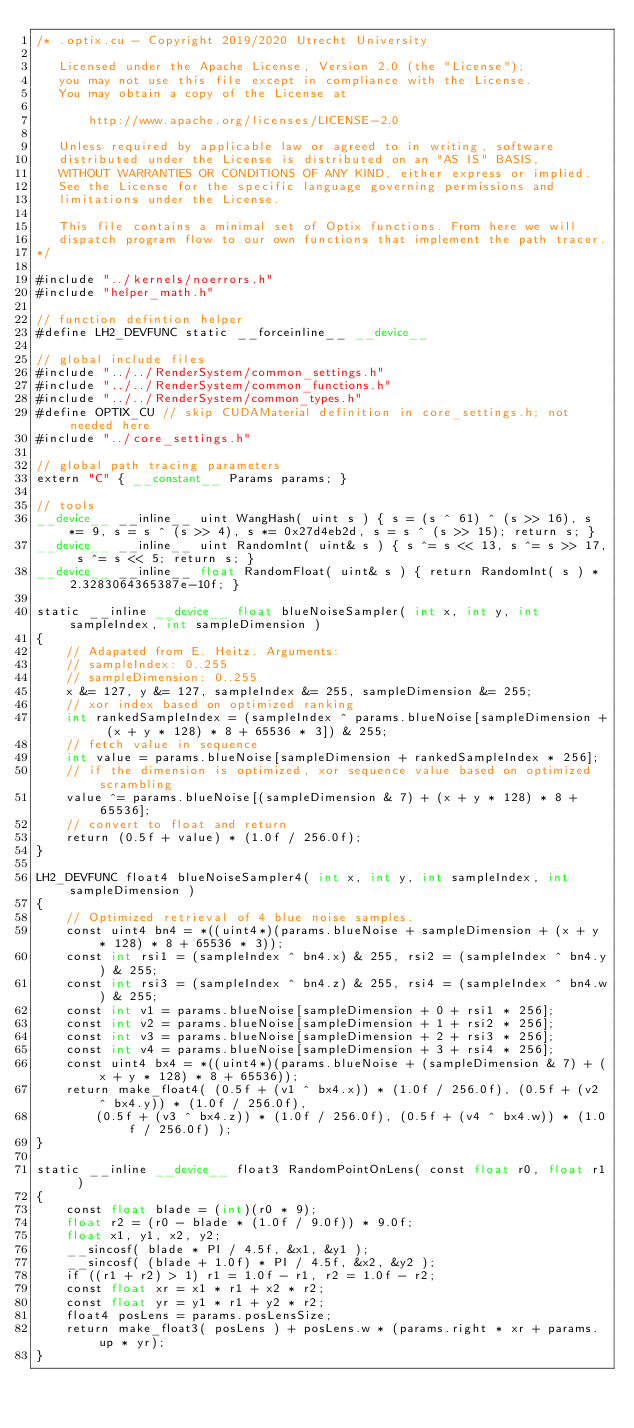Convert code to text. <code><loc_0><loc_0><loc_500><loc_500><_Cuda_>/* .optix.cu - Copyright 2019/2020 Utrecht University

   Licensed under the Apache License, Version 2.0 (the "License");
   you may not use this file except in compliance with the License.
   You may obtain a copy of the License at

	   http://www.apache.org/licenses/LICENSE-2.0

   Unless required by applicable law or agreed to in writing, software
   distributed under the License is distributed on an "AS IS" BASIS,
   WITHOUT WARRANTIES OR CONDITIONS OF ANY KIND, either express or implied.
   See the License for the specific language governing permissions and
   limitations under the License.

   This file contains a minimal set of Optix functions. From here we will
   dispatch program flow to our own functions that implement the path tracer.
*/

#include "../kernels/noerrors.h"
#include "helper_math.h"

// function defintion helper
#define LH2_DEVFUNC	static __forceinline__ __device__

// global include files
#include "../../RenderSystem/common_settings.h"
#include "../../RenderSystem/common_functions.h"
#include "../../RenderSystem/common_types.h"
#define OPTIX_CU // skip CUDAMaterial definition in core_settings.h; not needed here 
#include "../core_settings.h"

// global path tracing parameters
extern "C" { __constant__ Params params; }

// tools
__device__ __inline__ uint WangHash( uint s ) { s = (s ^ 61) ^ (s >> 16), s *= 9, s = s ^ (s >> 4), s *= 0x27d4eb2d, s = s ^ (s >> 15); return s; }
__device__ __inline__ uint RandomInt( uint& s ) { s ^= s << 13, s ^= s >> 17, s ^= s << 5; return s; }
__device__ __inline__ float RandomFloat( uint& s ) { return RandomInt( s ) * 2.3283064365387e-10f; }

static __inline __device__ float blueNoiseSampler( int x, int y, int sampleIndex, int sampleDimension )
{
	// Adapated from E. Heitz. Arguments:
	// sampleIndex: 0..255
	// sampleDimension: 0..255
	x &= 127, y &= 127, sampleIndex &= 255, sampleDimension &= 255;
	// xor index based on optimized ranking
	int rankedSampleIndex = (sampleIndex ^ params.blueNoise[sampleDimension + (x + y * 128) * 8 + 65536 * 3]) & 255;
	// fetch value in sequence
	int value = params.blueNoise[sampleDimension + rankedSampleIndex * 256];
	// if the dimension is optimized, xor sequence value based on optimized scrambling
	value ^= params.blueNoise[(sampleDimension & 7) + (x + y * 128) * 8 + 65536];
	// convert to float and return
	return (0.5f + value) * (1.0f / 256.0f);
}

LH2_DEVFUNC float4 blueNoiseSampler4( int x, int y, int sampleIndex, int sampleDimension )
{
	// Optimized retrieval of 4 blue noise samples.
	const uint4 bn4 = *((uint4*)(params.blueNoise + sampleDimension + (x + y * 128) * 8 + 65536 * 3));
	const int rsi1 = (sampleIndex ^ bn4.x) & 255, rsi2 = (sampleIndex ^ bn4.y) & 255;
	const int rsi3 = (sampleIndex ^ bn4.z) & 255, rsi4 = (sampleIndex ^ bn4.w) & 255;
	const int v1 = params.blueNoise[sampleDimension + 0 + rsi1 * 256];
	const int v2 = params.blueNoise[sampleDimension + 1 + rsi2 * 256];
	const int v3 = params.blueNoise[sampleDimension + 2 + rsi3 * 256];
	const int v4 = params.blueNoise[sampleDimension + 3 + rsi4 * 256];
	const uint4 bx4 = *((uint4*)(params.blueNoise + (sampleDimension & 7) + (x + y * 128) * 8 + 65536));
	return make_float4( (0.5f + (v1 ^ bx4.x)) * (1.0f / 256.0f), (0.5f + (v2 ^ bx4.y)) * (1.0f / 256.0f),
		(0.5f + (v3 ^ bx4.z)) * (1.0f / 256.0f), (0.5f + (v4 ^ bx4.w)) * (1.0f / 256.0f) );
}

static __inline __device__ float3 RandomPointOnLens( const float r0, float r1 )
{
	const float blade = (int)(r0 * 9);
	float r2 = (r0 - blade * (1.0f / 9.0f)) * 9.0f;
	float x1, y1, x2, y2;
	__sincosf( blade * PI / 4.5f, &x1, &y1 );
	__sincosf( (blade + 1.0f) * PI / 4.5f, &x2, &y2 );
	if ((r1 + r2) > 1) r1 = 1.0f - r1, r2 = 1.0f - r2;
	const float xr = x1 * r1 + x2 * r2;
	const float yr = y1 * r1 + y2 * r2;
	float4 posLens = params.posLensSize;
	return make_float3( posLens ) + posLens.w * (params.right * xr + params.up * yr);
}
</code> 